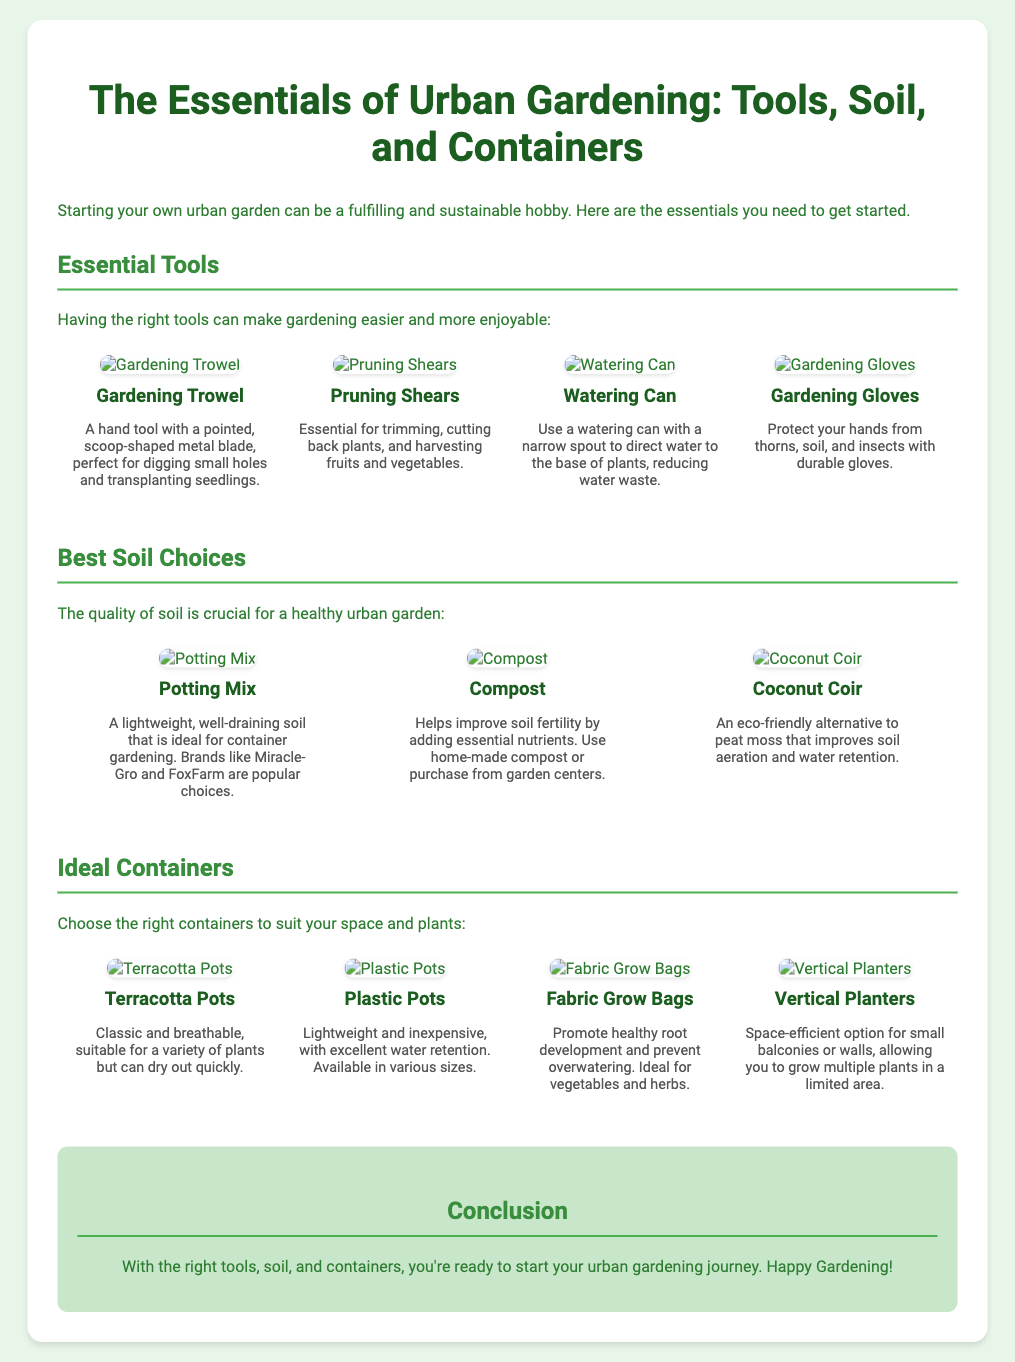What are the essential tools for urban gardening? The essential tools listed in the document include a gardening trowel, pruning shears, watering can, and gardening gloves.
Answer: Gardening trowel, pruning shears, watering can, gardening gloves Which soil type is considered lightweight and well-draining? The document mentions potting mix as a lightweight, well-draining soil ideal for container gardening.
Answer: Potting mix What are the benefits of using compost in urban gardening? According to the document, compost helps improve soil fertility by adding essential nutrients.
Answer: Improves soil fertility Which type of container promotes healthy root development? The document describes fabric grow bags as promoting healthy root development and preventing overwatering.
Answer: Fabric grow bags How many types of containers are mentioned in the document? There are four types of containers listed in the document: terracotta pots, plastic pots, fabric grow bags, and vertical planters.
Answer: Four What is the purpose of a watering can? The document states that a watering can with a narrow spout is used to direct water to the base of plants, reducing water waste.
Answer: Direct water to the base of plants What is the conclusion of the presentation slide? The conclusion emphasizes that with the right tools, soil, and containers, one is ready to start their urban gardening journey.
Answer: Happy Gardening! What is a key feature of vertical planters? The document highlights that vertical planters are space-efficient options for small balconies or walls.
Answer: Space-efficient 